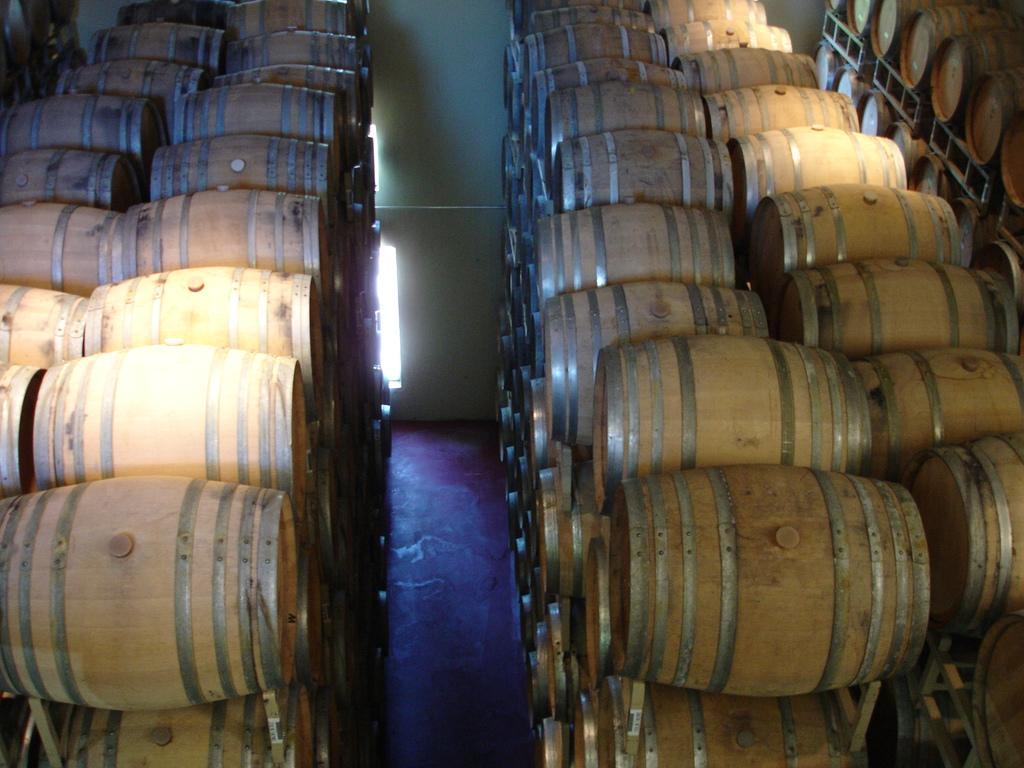Could you give a brief overview of what you see in this image? In this image I can see many barrels. There is a white background. 